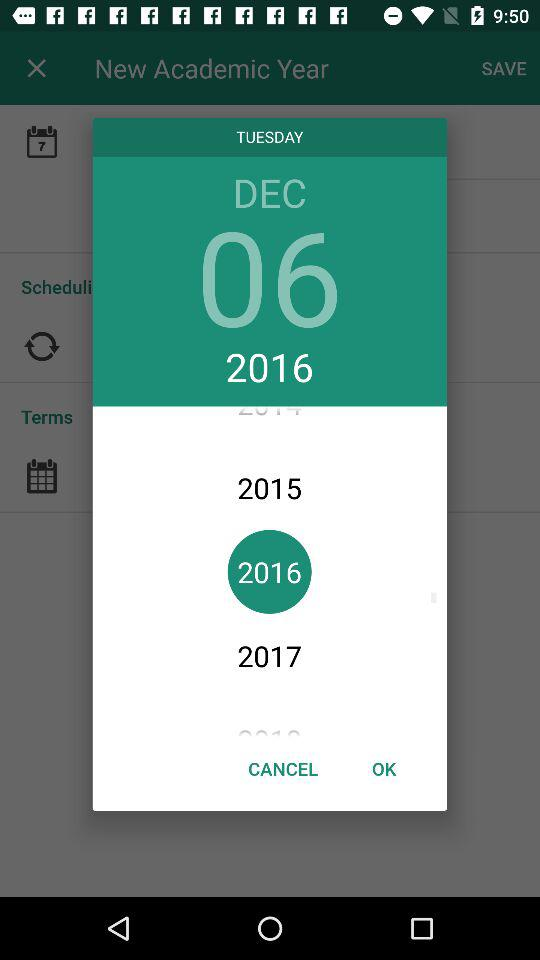What is the day on the selected date? The day is "TUESDAY". 